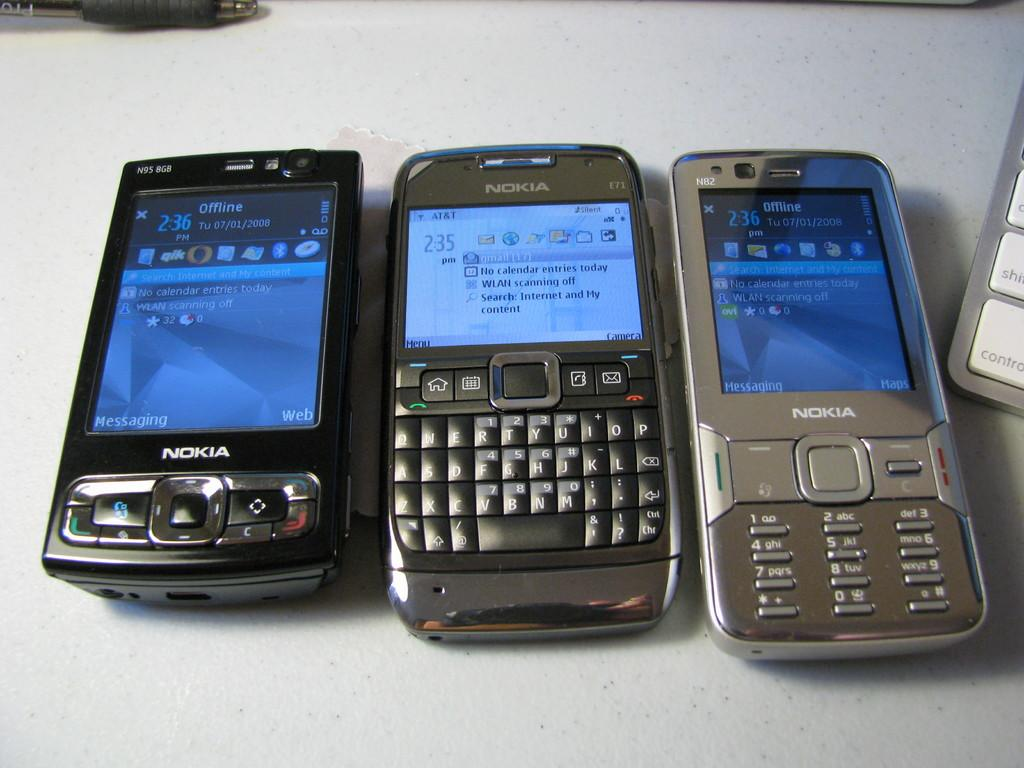<image>
Provide a brief description of the given image. three nokia phones side by side on a white background next to a keyboard 